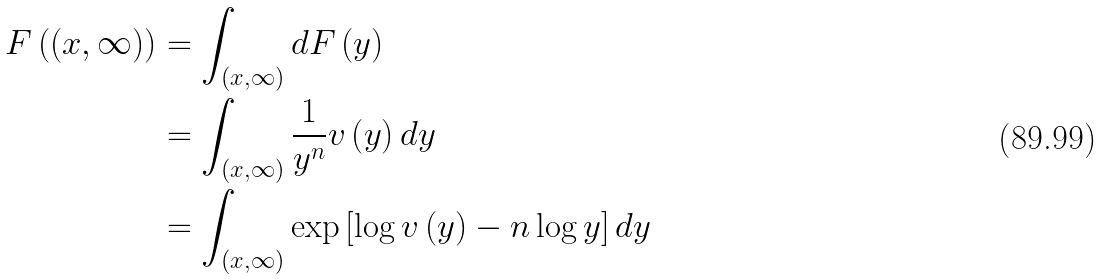Convert formula to latex. <formula><loc_0><loc_0><loc_500><loc_500>F \left ( ( x , \infty ) \right ) & = \int _ { ( x , \infty ) } d F \left ( y \right ) \\ & = \int _ { ( x , \infty ) } \frac { 1 } { y ^ { n } } v \left ( y \right ) d y \\ & = \int _ { ( x , \infty ) } \exp \left [ \log v \left ( y \right ) - n \log y \right ] d y</formula> 